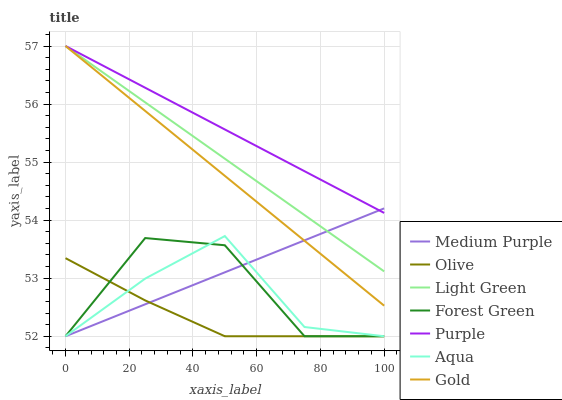Does Olive have the minimum area under the curve?
Answer yes or no. Yes. Does Purple have the maximum area under the curve?
Answer yes or no. Yes. Does Aqua have the minimum area under the curve?
Answer yes or no. No. Does Aqua have the maximum area under the curve?
Answer yes or no. No. Is Gold the smoothest?
Answer yes or no. Yes. Is Forest Green the roughest?
Answer yes or no. Yes. Is Aqua the smoothest?
Answer yes or no. No. Is Aqua the roughest?
Answer yes or no. No. Does Aqua have the lowest value?
Answer yes or no. Yes. Does Purple have the lowest value?
Answer yes or no. No. Does Light Green have the highest value?
Answer yes or no. Yes. Does Aqua have the highest value?
Answer yes or no. No. Is Olive less than Light Green?
Answer yes or no. Yes. Is Gold greater than Aqua?
Answer yes or no. Yes. Does Aqua intersect Olive?
Answer yes or no. Yes. Is Aqua less than Olive?
Answer yes or no. No. Is Aqua greater than Olive?
Answer yes or no. No. Does Olive intersect Light Green?
Answer yes or no. No. 